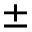<formula> <loc_0><loc_0><loc_500><loc_500>\pm</formula> 